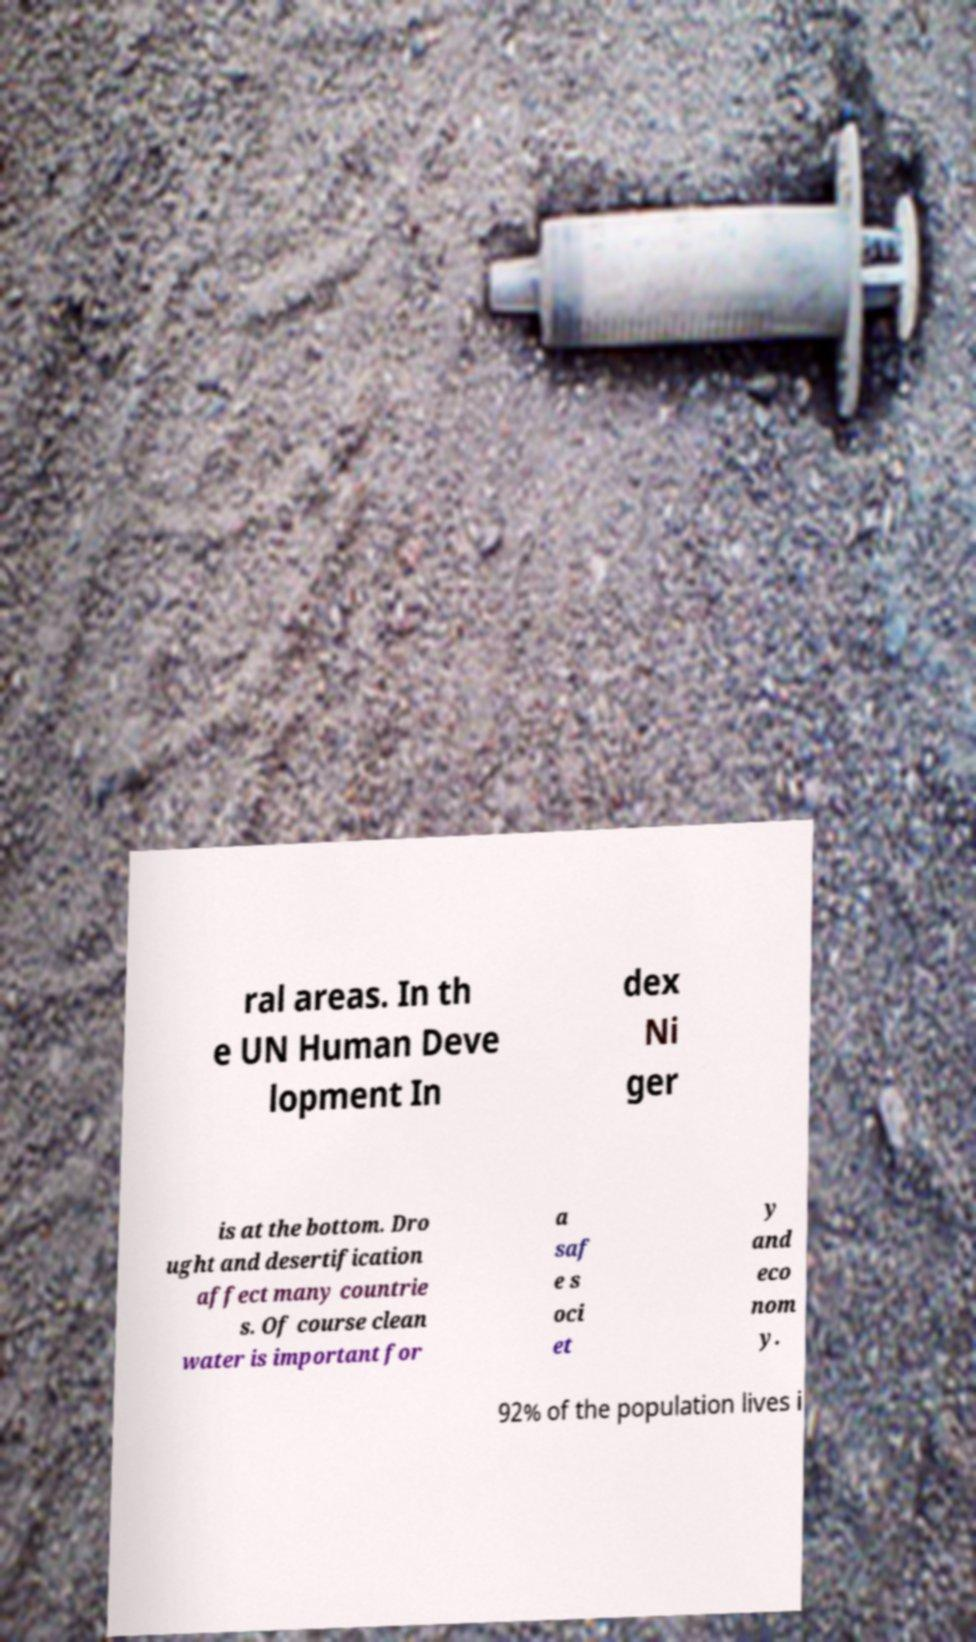There's text embedded in this image that I need extracted. Can you transcribe it verbatim? ral areas. In th e UN Human Deve lopment In dex Ni ger is at the bottom. Dro ught and desertification affect many countrie s. Of course clean water is important for a saf e s oci et y and eco nom y. 92% of the population lives i 